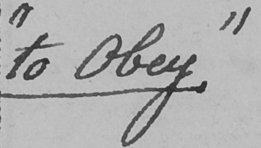Can you read and transcribe this handwriting? " to Obey . " 